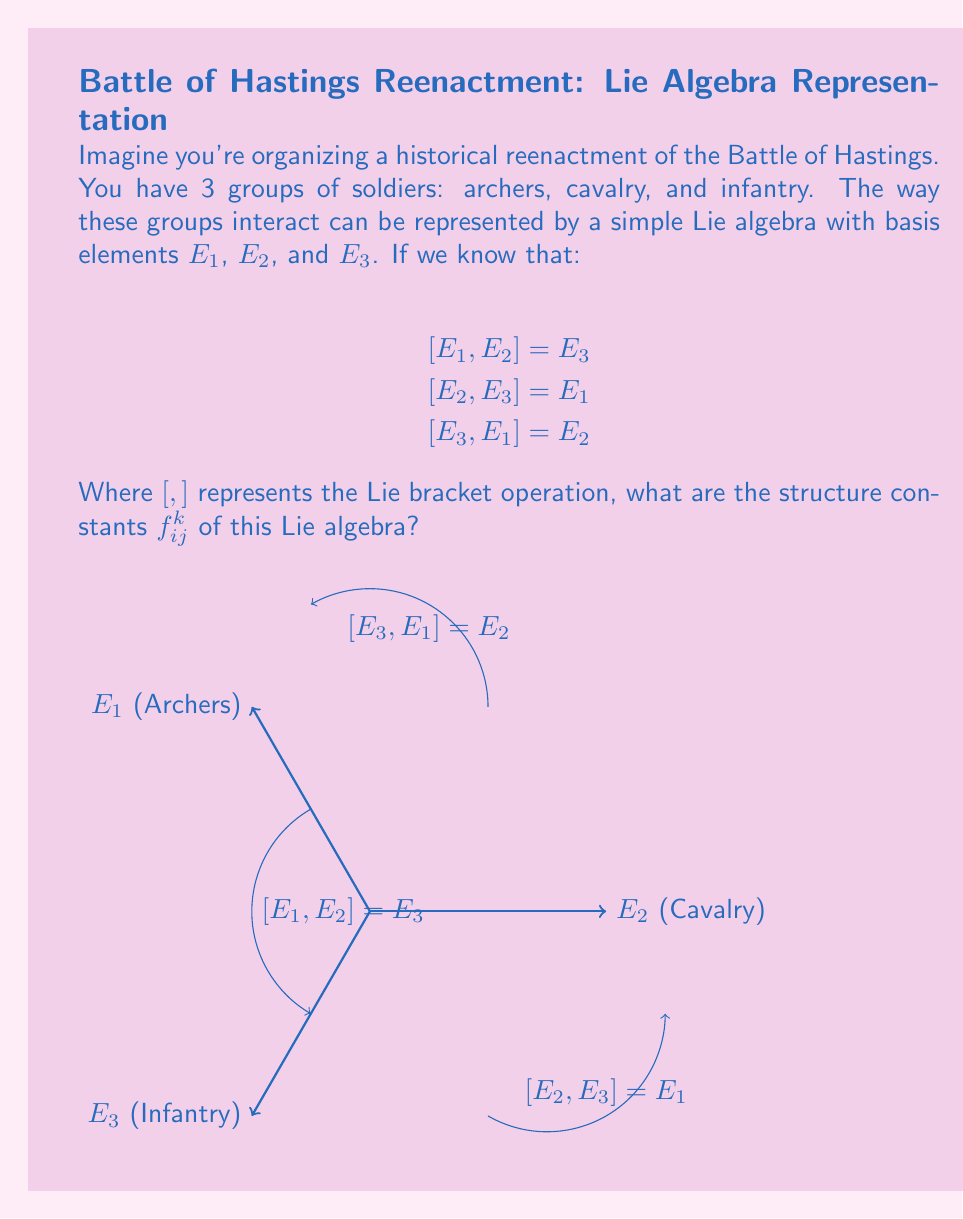Give your solution to this math problem. Let's approach this step-by-step:

1) The structure constants $f_{ij}^k$ are defined by the equation:

   $$[E_i, E_j] = \sum_k f_{ij}^k E_k$$

2) From the given relations, we can identify:

   $$[E_1, E_2] = E_3 \implies f_{12}^3 = 1$$
   $$[E_2, E_3] = E_1 \implies f_{23}^1 = 1$$
   $$[E_3, E_1] = E_2 \implies f_{31}^2 = 1$$

3) Due to the antisymmetry of the Lie bracket, we also have:

   $$[E_2, E_1] = -E_3 \implies f_{21}^3 = -1$$
   $$[E_3, E_2] = -E_1 \implies f_{32}^1 = -1$$
   $$[E_1, E_3] = -E_2 \implies f_{13}^2 = -1$$

4) All other structure constants are zero. For example:

   $$[E_1, E_1] = 0 \implies f_{11}^k = 0 \text{ for all } k$$

5) Therefore, the non-zero structure constants are:

   $$f_{12}^3 = f_{23}^1 = f_{31}^2 = 1$$
   $$f_{21}^3 = f_{32}^1 = f_{13}^2 = -1$$

This set of structure constants defines what's known as the $\mathfrak{so}(3)$ Lie algebra, which describes rotations in 3-dimensional space.
Answer: $f_{12}^3 = f_{23}^1 = f_{31}^2 = 1$, $f_{21}^3 = f_{32}^1 = f_{13}^2 = -1$, all others zero 